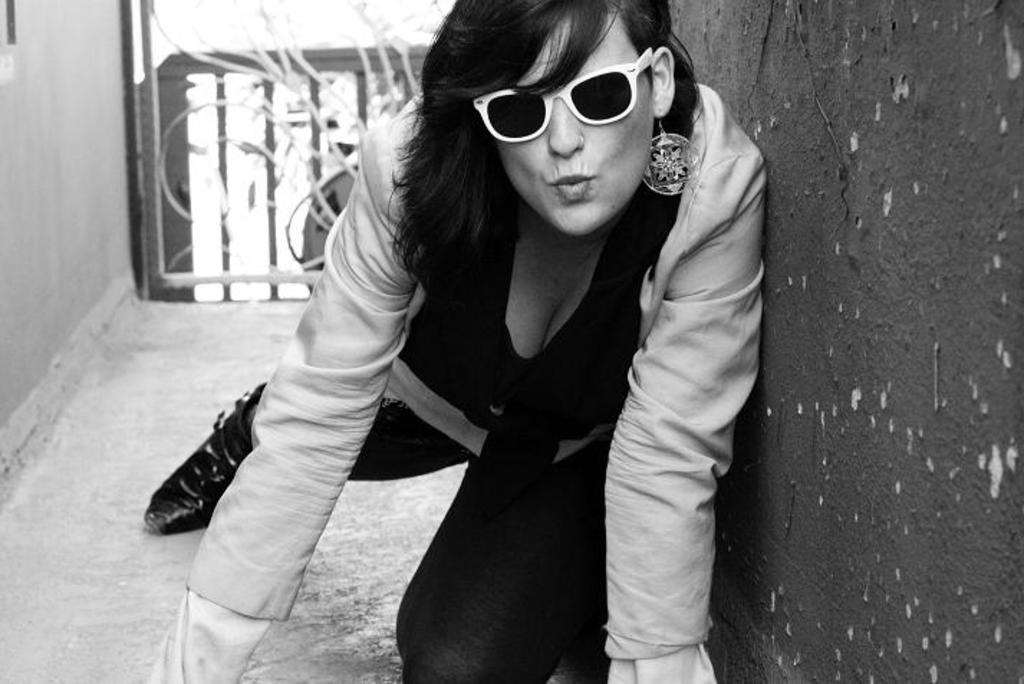How would you summarize this image in a sentence or two? In the center of the image we can see a person is wearing glasses. On the right side of the image, there is a wall. In the background, we can see some objects. 